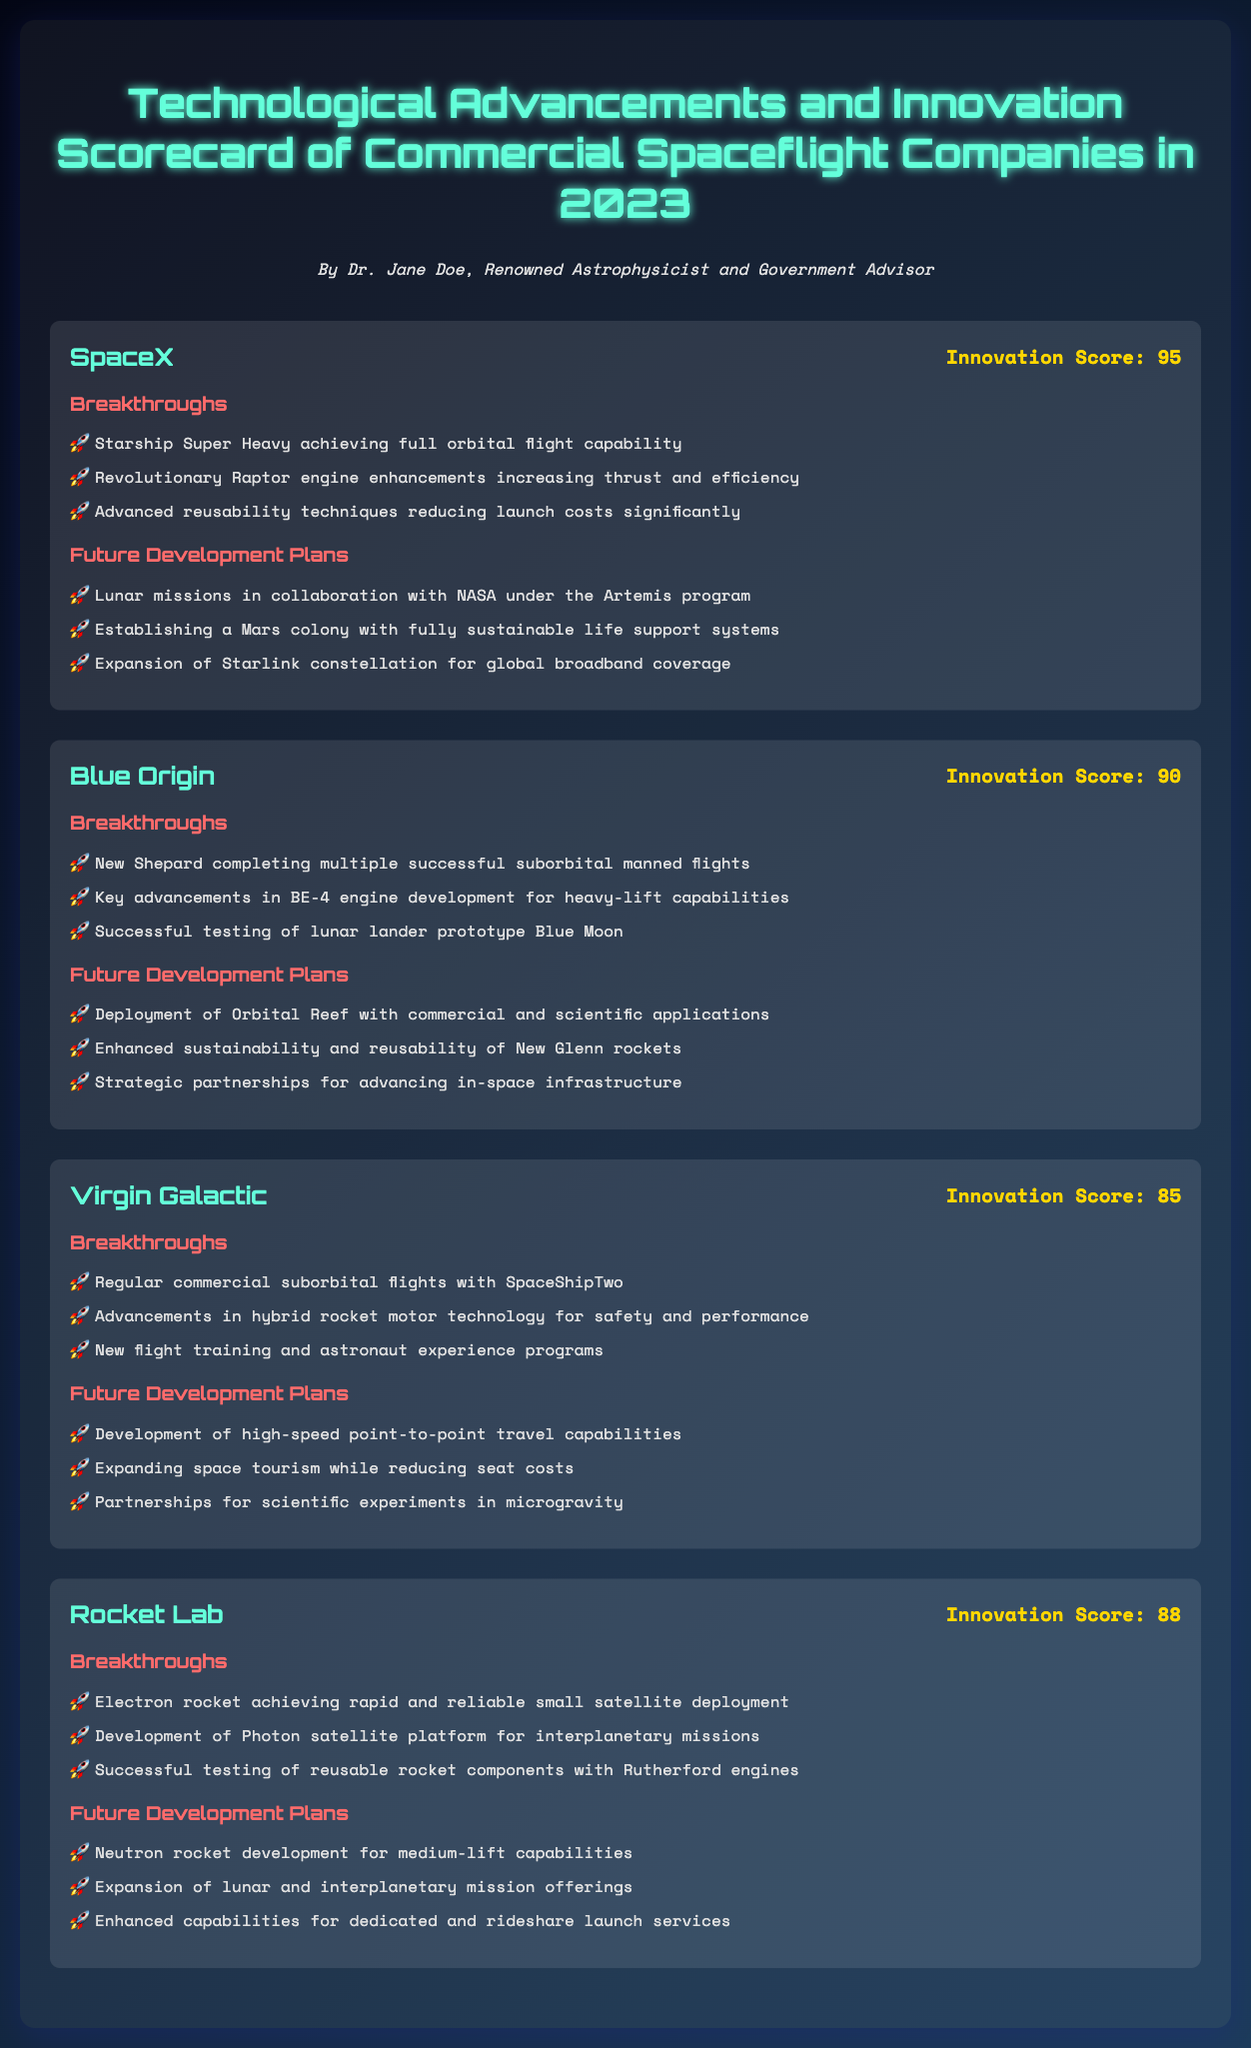What is SpaceX's innovation score? The innovation score for SpaceX is explicitly stated in the document.
Answer: 95 What significant breakthrough did Blue Origin achieve in 2023? The document lists key breakthroughs for each company, including specific achievements.
Answer: New Shepard completing multiple successful suborbital manned flights What is Virgin Galactic's future development plan related to space tourism? The document outlines various future plans for each company, including specific initiatives for space tourism.
Answer: Expanding space tourism while reducing seat costs How many breakthroughs does Rocket Lab have listed in the document? The document provides a list of breakthroughs for Rocket Lab, which is relevant to the context of the inquiry.
Answer: 3 Which company's future plans include a lunar mission in collaboration with NASA? The document associates future plans for each company with specific collaborators or projects.
Answer: SpaceX What advancements does Blue Origin emphasize in their BE-4 engine? The document highlights key advancements made by each company, focusing on engine developments.
Answer: Heavy-lift capabilities What mission capability is mentioned for Rocket Lab's Photon satellite platform? This question requires recalling specific technological developments mentioned within Rocket Lab's section.
Answer: Interplanetary missions How many successful manned flights has Virgin Galactic completed with SpaceShipTwo? The document references a significant achievement of Virgin Galactic regarding their flights.
Answer: Multiple What type of innovative technology has Virgin Galactic developed for safety and performance? The document lists specific technological advancements by Virgin Galactic related to their flight operations.
Answer: Hybrid rocket motor technology 